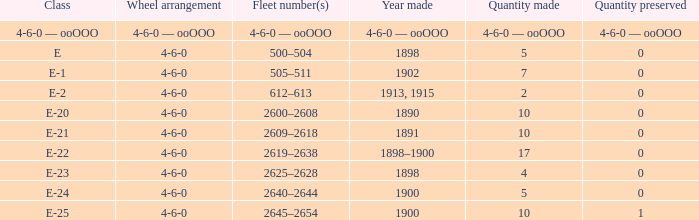What is the quantity made of the e-22 class, which has a quantity preserved of 0? 17.0. 